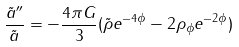<formula> <loc_0><loc_0><loc_500><loc_500>\frac { \tilde { a } ^ { \prime \prime } } { \tilde { a } } = - \frac { 4 \pi G } { 3 } ( \tilde { \rho } e ^ { - 4 \phi } - 2 \rho _ { \phi } e ^ { - 2 \phi } )</formula> 